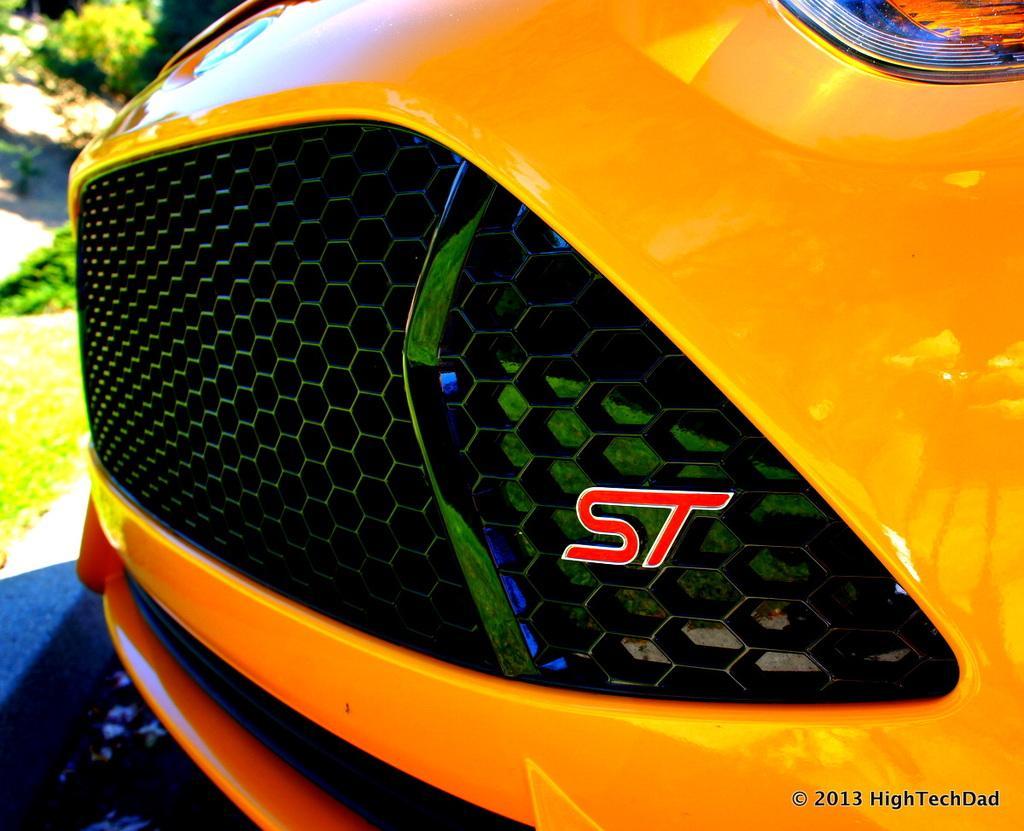Describe this image in one or two sentences. In this image we can see the bumper of a car. On the left side we can see some plants and grass. On the bottom of the image we can see some text. 